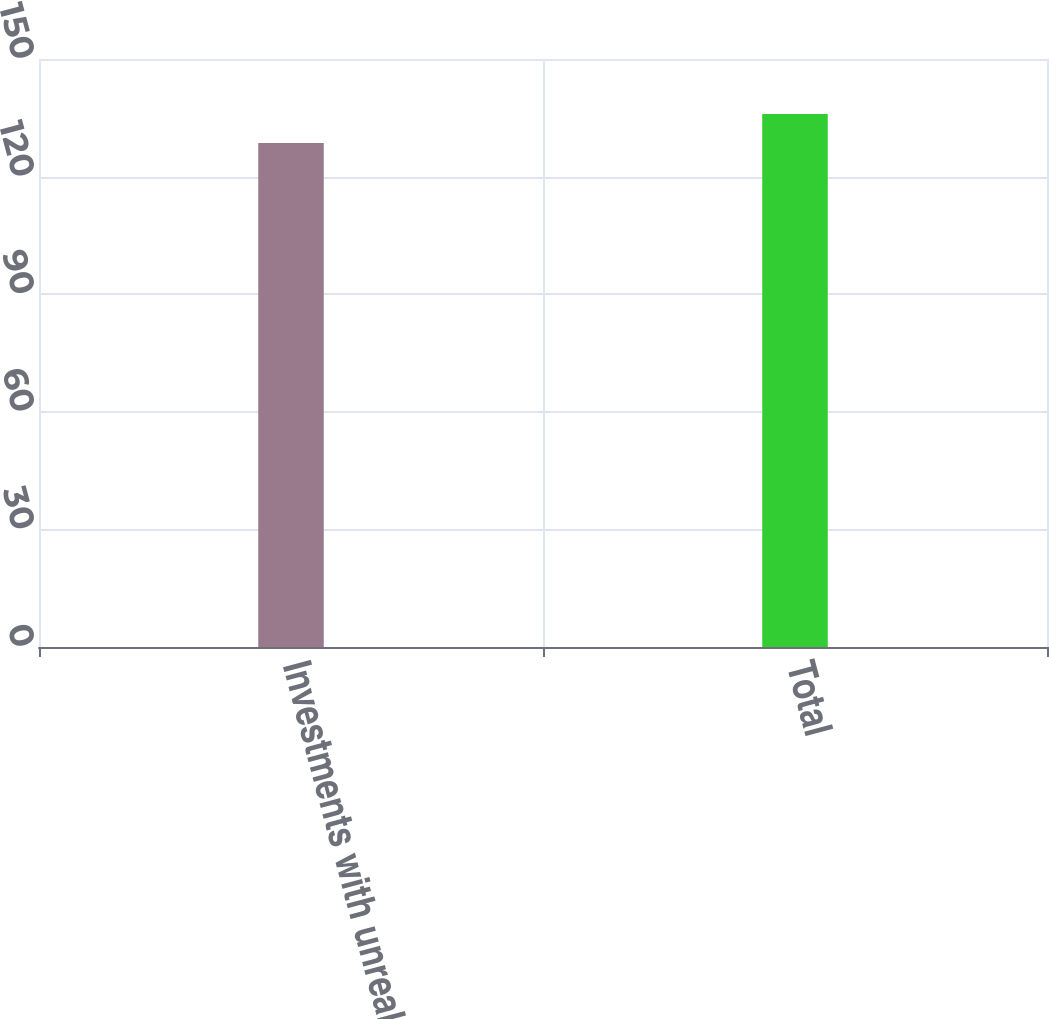Convert chart to OTSL. <chart><loc_0><loc_0><loc_500><loc_500><bar_chart><fcel>Investments with unrealized<fcel>Total<nl><fcel>128.6<fcel>136<nl></chart> 